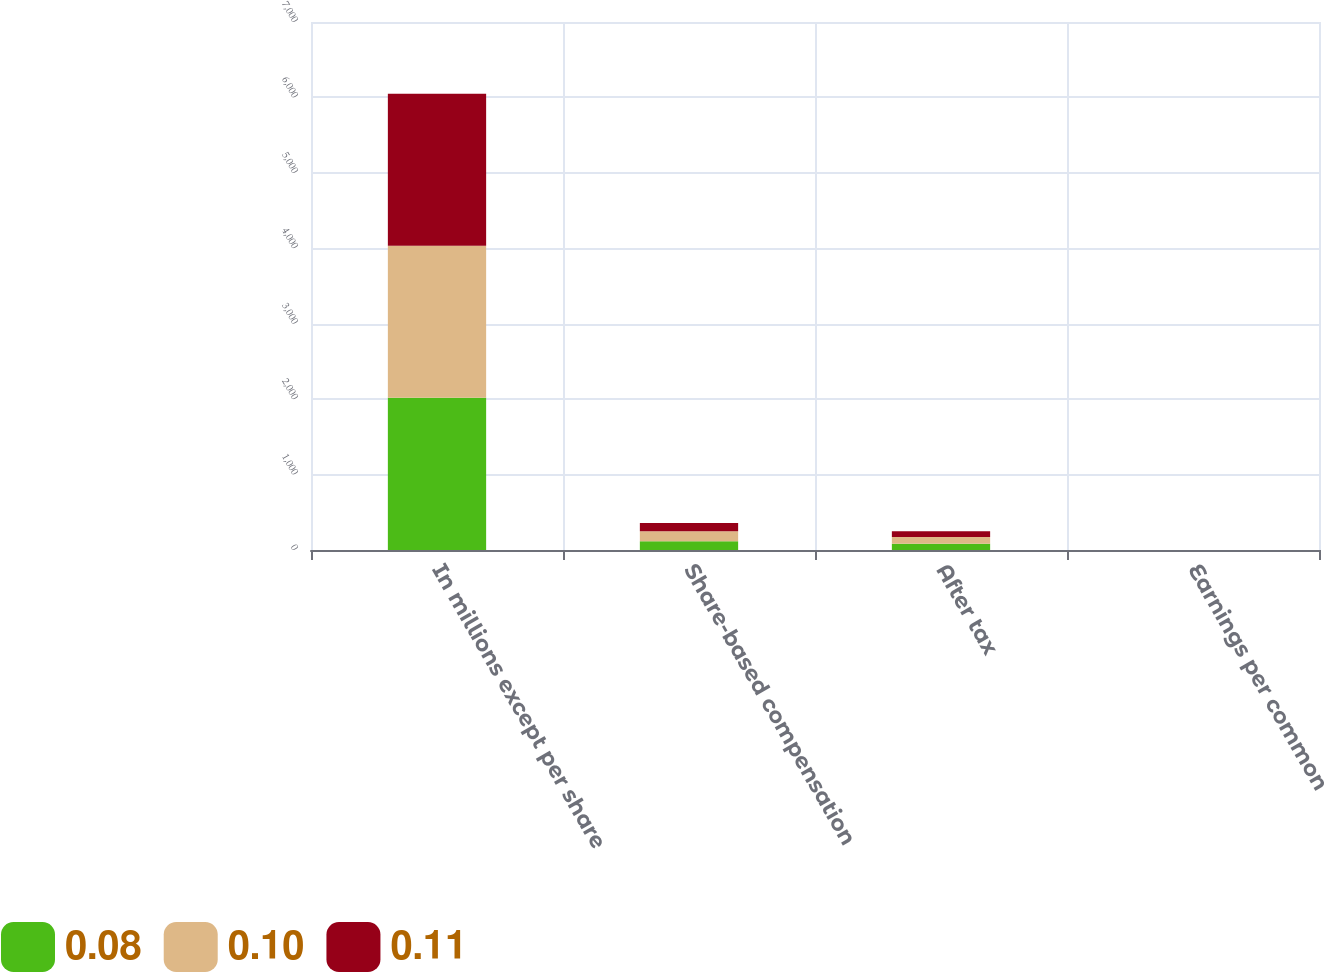Convert chart to OTSL. <chart><loc_0><loc_0><loc_500><loc_500><stacked_bar_chart><ecel><fcel>In millions except per share<fcel>Share-based compensation<fcel>After tax<fcel>Earnings per common<nl><fcel>0.08<fcel>2017<fcel>117.5<fcel>82<fcel>0.1<nl><fcel>0.1<fcel>2016<fcel>131.3<fcel>89.6<fcel>0.11<nl><fcel>0.11<fcel>2015<fcel>110<fcel>76<fcel>0.08<nl></chart> 